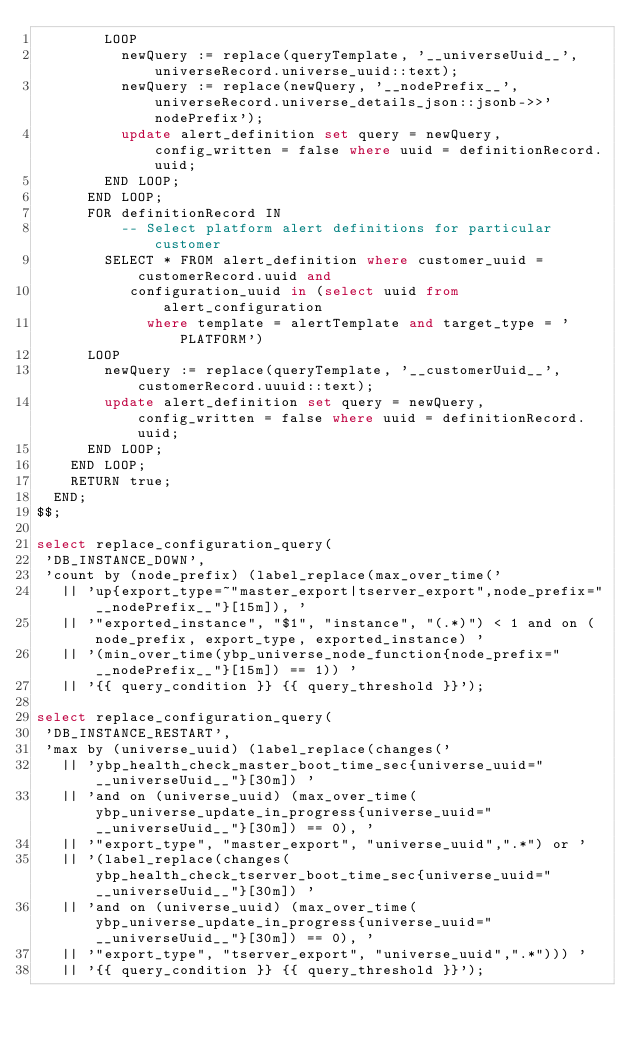Convert code to text. <code><loc_0><loc_0><loc_500><loc_500><_SQL_>        LOOP
          newQuery := replace(queryTemplate, '__universeUuid__', universeRecord.universe_uuid::text);
          newQuery := replace(newQuery, '__nodePrefix__', universeRecord.universe_details_json::jsonb->>'nodePrefix');
          update alert_definition set query = newQuery, config_written = false where uuid = definitionRecord.uuid;
        END LOOP;
      END LOOP;
      FOR definitionRecord IN
          -- Select platform alert definitions for particular customer
        SELECT * FROM alert_definition where customer_uuid = customerRecord.uuid and
           configuration_uuid in (select uuid from alert_configuration
             where template = alertTemplate and target_type = 'PLATFORM')
      LOOP
        newQuery := replace(queryTemplate, '__customerUuid__', customerRecord.uuuid::text);
        update alert_definition set query = newQuery, config_written = false where uuid = definitionRecord.uuid;
      END LOOP;
    END LOOP;
    RETURN true;
  END;
$$;

select replace_configuration_query(
 'DB_INSTANCE_DOWN',
 'count by (node_prefix) (label_replace(max_over_time('
   || 'up{export_type=~"master_export|tserver_export",node_prefix="__nodePrefix__"}[15m]), '
   || '"exported_instance", "$1", "instance", "(.*)") < 1 and on (node_prefix, export_type, exported_instance) '
   || '(min_over_time(ybp_universe_node_function{node_prefix="__nodePrefix__"}[15m]) == 1)) '
   || '{{ query_condition }} {{ query_threshold }}');

select replace_configuration_query(
 'DB_INSTANCE_RESTART',
 'max by (universe_uuid) (label_replace(changes('
   || 'ybp_health_check_master_boot_time_sec{universe_uuid="__universeUuid__"}[30m]) '
   || 'and on (universe_uuid) (max_over_time(ybp_universe_update_in_progress{universe_uuid="__universeUuid__"}[30m]) == 0), '
   || '"export_type", "master_export", "universe_uuid",".*") or '
   || '(label_replace(changes(ybp_health_check_tserver_boot_time_sec{universe_uuid="__universeUuid__"}[30m]) '
   || 'and on (universe_uuid) (max_over_time(ybp_universe_update_in_progress{universe_uuid="__universeUuid__"}[30m]) == 0), '
   || '"export_type", "tserver_export", "universe_uuid",".*"))) '
   || '{{ query_condition }} {{ query_threshold }}');
</code> 